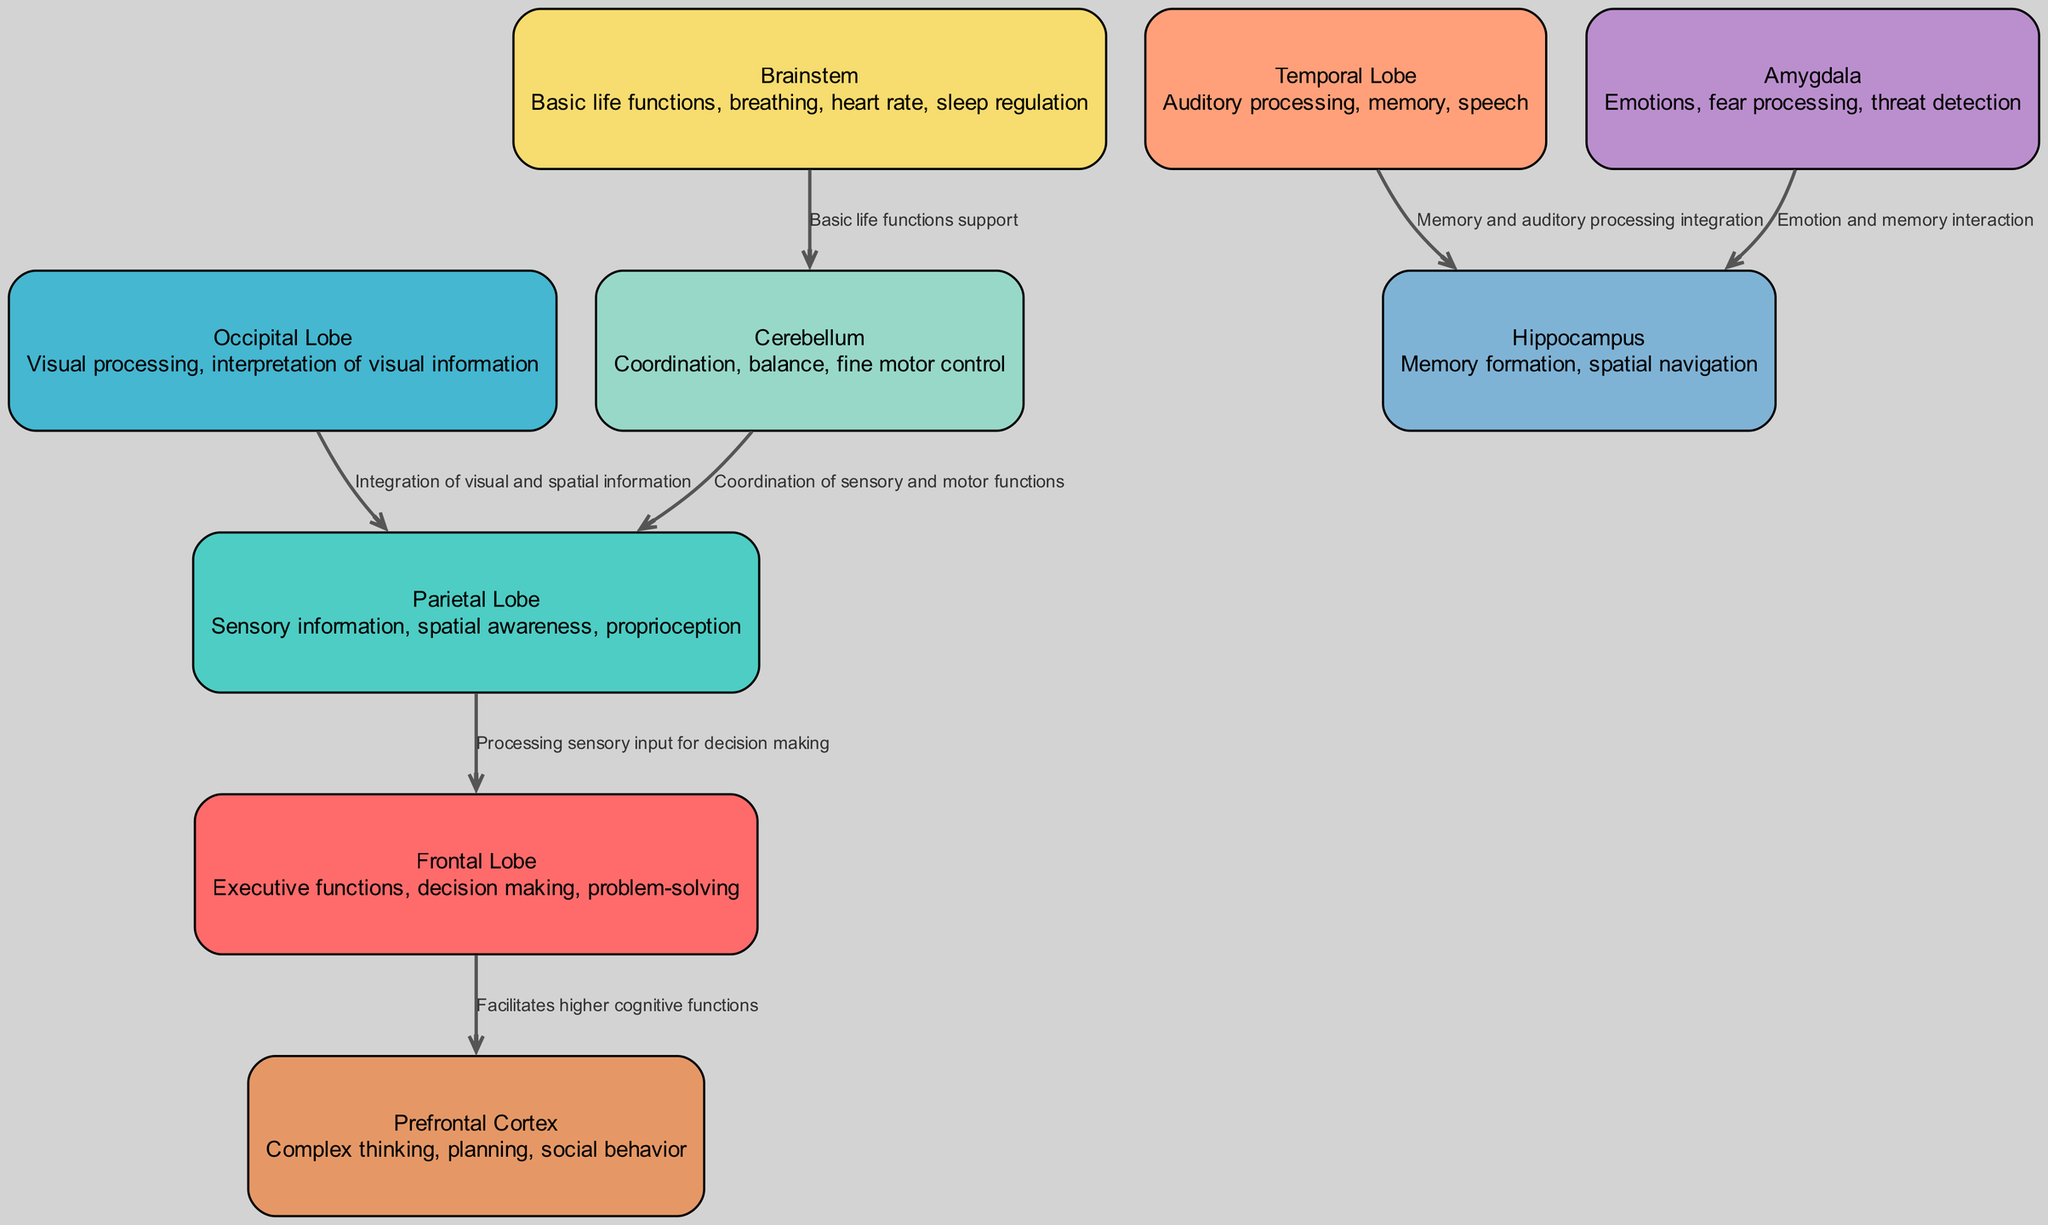What is the role of the frontal lobe? The frontal lobe is responsible for executive functions, decision-making, and problem-solving. These functions are critical for higher cognitive processes, as indicated in the diagram description for this lobe.
Answer: Executive functions, decision making, problem-solving How many nodes are there in the diagram? By counting the nodes listed in the data, we see that there are 9 distinct nodes representing various brain regions.
Answer: 9 What is the connection between the amygdala and the hippocampus? The diagram shows that the amygdala connects to the hippocampus for the interaction of emotion and memory. This connection highlights how emotions influence memory formation.
Answer: Emotion and memory interaction Which lobe is responsible for spatial awareness? The parietal lobe is indicated in the diagram to handle sensory information, including spatial awareness, as described in its corresponding node.
Answer: Parietal Lobe What integrates visual and spatial information? The diagram illustrates that the occipital lobe integrates with the parietal lobe to combine visual data with spatial orientation, allowing for better navigation and understanding of our surroundings.
Answer: Integration of visual and spatial information How does the brainstem support the cerebellum? The connection in the diagram indicates that the brainstem supports the cerebellum by regulating basic life functions, ensuring the cerebellum can perform its role in coordination and balance effectively.
Answer: Basic life functions support What facilitates higher cognitive functions? The diagram explicitly states that the frontal lobe facilitates higher cognitive functions by connecting to the prefrontal cortex, which is associated with complex thinking and planning.
Answer: Facilitates higher cognitive functions Which brain region is involved with memory formation? The hippocampus is recognized in the diagram for its key role in memory formation, as described in its node description.
Answer: Hippocampus 